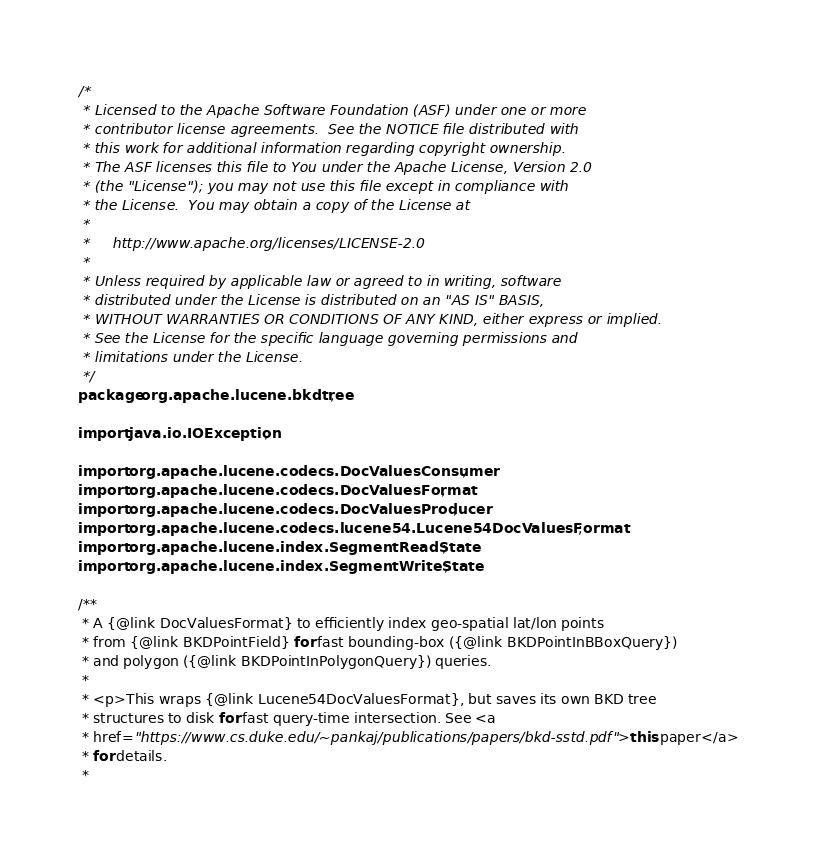Convert code to text. <code><loc_0><loc_0><loc_500><loc_500><_Java_>/*
 * Licensed to the Apache Software Foundation (ASF) under one or more
 * contributor license agreements.  See the NOTICE file distributed with
 * this work for additional information regarding copyright ownership.
 * The ASF licenses this file to You under the Apache License, Version 2.0
 * (the "License"); you may not use this file except in compliance with
 * the License.  You may obtain a copy of the License at
 *
 *     http://www.apache.org/licenses/LICENSE-2.0
 *
 * Unless required by applicable law or agreed to in writing, software
 * distributed under the License is distributed on an "AS IS" BASIS,
 * WITHOUT WARRANTIES OR CONDITIONS OF ANY KIND, either express or implied.
 * See the License for the specific language governing permissions and
 * limitations under the License.
 */
package org.apache.lucene.bkdtree;

import java.io.IOException;

import org.apache.lucene.codecs.DocValuesConsumer;
import org.apache.lucene.codecs.DocValuesFormat;
import org.apache.lucene.codecs.DocValuesProducer;
import org.apache.lucene.codecs.lucene54.Lucene54DocValuesFormat;
import org.apache.lucene.index.SegmentReadState;
import org.apache.lucene.index.SegmentWriteState;

/**
 * A {@link DocValuesFormat} to efficiently index geo-spatial lat/lon points
 * from {@link BKDPointField} for fast bounding-box ({@link BKDPointInBBoxQuery})
 * and polygon ({@link BKDPointInPolygonQuery}) queries.
 *
 * <p>This wraps {@link Lucene54DocValuesFormat}, but saves its own BKD tree
 * structures to disk for fast query-time intersection. See <a
 * href="https://www.cs.duke.edu/~pankaj/publications/papers/bkd-sstd.pdf">this paper</a>
 * for details.
 *</code> 